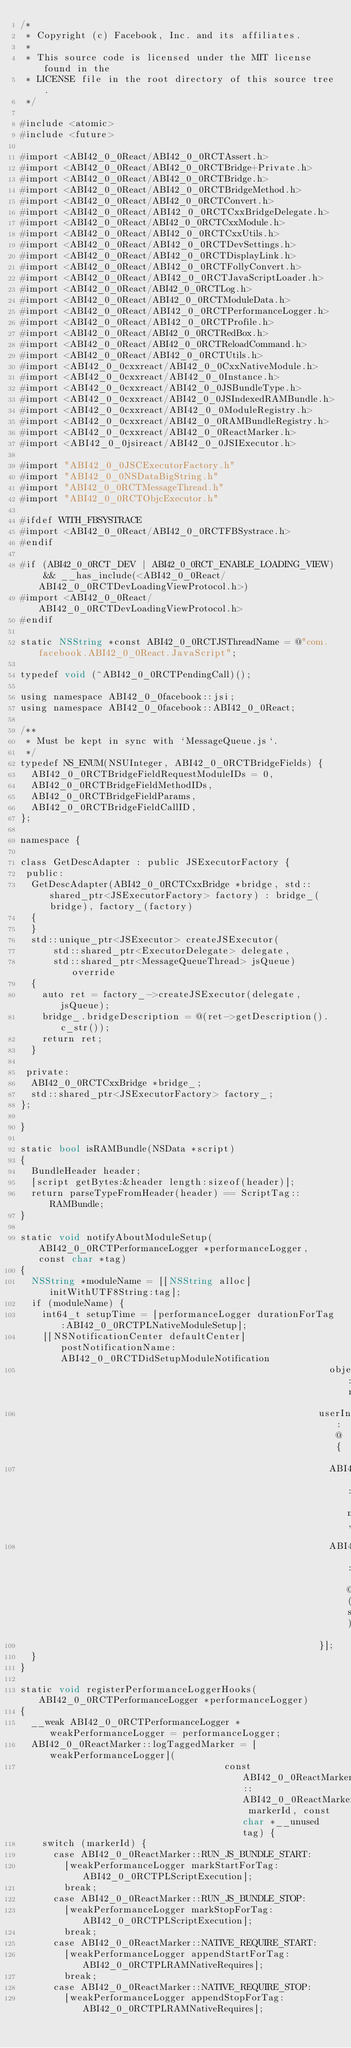Convert code to text. <code><loc_0><loc_0><loc_500><loc_500><_ObjectiveC_>/*
 * Copyright (c) Facebook, Inc. and its affiliates.
 *
 * This source code is licensed under the MIT license found in the
 * LICENSE file in the root directory of this source tree.
 */

#include <atomic>
#include <future>

#import <ABI42_0_0React/ABI42_0_0RCTAssert.h>
#import <ABI42_0_0React/ABI42_0_0RCTBridge+Private.h>
#import <ABI42_0_0React/ABI42_0_0RCTBridge.h>
#import <ABI42_0_0React/ABI42_0_0RCTBridgeMethod.h>
#import <ABI42_0_0React/ABI42_0_0RCTConvert.h>
#import <ABI42_0_0React/ABI42_0_0RCTCxxBridgeDelegate.h>
#import <ABI42_0_0React/ABI42_0_0RCTCxxModule.h>
#import <ABI42_0_0React/ABI42_0_0RCTCxxUtils.h>
#import <ABI42_0_0React/ABI42_0_0RCTDevSettings.h>
#import <ABI42_0_0React/ABI42_0_0RCTDisplayLink.h>
#import <ABI42_0_0React/ABI42_0_0RCTFollyConvert.h>
#import <ABI42_0_0React/ABI42_0_0RCTJavaScriptLoader.h>
#import <ABI42_0_0React/ABI42_0_0RCTLog.h>
#import <ABI42_0_0React/ABI42_0_0RCTModuleData.h>
#import <ABI42_0_0React/ABI42_0_0RCTPerformanceLogger.h>
#import <ABI42_0_0React/ABI42_0_0RCTProfile.h>
#import <ABI42_0_0React/ABI42_0_0RCTRedBox.h>
#import <ABI42_0_0React/ABI42_0_0RCTReloadCommand.h>
#import <ABI42_0_0React/ABI42_0_0RCTUtils.h>
#import <ABI42_0_0cxxreact/ABI42_0_0CxxNativeModule.h>
#import <ABI42_0_0cxxreact/ABI42_0_0Instance.h>
#import <ABI42_0_0cxxreact/ABI42_0_0JSBundleType.h>
#import <ABI42_0_0cxxreact/ABI42_0_0JSIndexedRAMBundle.h>
#import <ABI42_0_0cxxreact/ABI42_0_0ModuleRegistry.h>
#import <ABI42_0_0cxxreact/ABI42_0_0RAMBundleRegistry.h>
#import <ABI42_0_0cxxreact/ABI42_0_0ReactMarker.h>
#import <ABI42_0_0jsireact/ABI42_0_0JSIExecutor.h>

#import "ABI42_0_0JSCExecutorFactory.h"
#import "ABI42_0_0NSDataBigString.h"
#import "ABI42_0_0RCTMessageThread.h"
#import "ABI42_0_0RCTObjcExecutor.h"

#ifdef WITH_FBSYSTRACE
#import <ABI42_0_0React/ABI42_0_0RCTFBSystrace.h>
#endif

#if (ABI42_0_0RCT_DEV | ABI42_0_0RCT_ENABLE_LOADING_VIEW) && __has_include(<ABI42_0_0React/ABI42_0_0RCTDevLoadingViewProtocol.h>)
#import <ABI42_0_0React/ABI42_0_0RCTDevLoadingViewProtocol.h>
#endif

static NSString *const ABI42_0_0RCTJSThreadName = @"com.facebook.ABI42_0_0React.JavaScript";

typedef void (^ABI42_0_0RCTPendingCall)();

using namespace ABI42_0_0facebook::jsi;
using namespace ABI42_0_0facebook::ABI42_0_0React;

/**
 * Must be kept in sync with `MessageQueue.js`.
 */
typedef NS_ENUM(NSUInteger, ABI42_0_0RCTBridgeFields) {
  ABI42_0_0RCTBridgeFieldRequestModuleIDs = 0,
  ABI42_0_0RCTBridgeFieldMethodIDs,
  ABI42_0_0RCTBridgeFieldParams,
  ABI42_0_0RCTBridgeFieldCallID,
};

namespace {

class GetDescAdapter : public JSExecutorFactory {
 public:
  GetDescAdapter(ABI42_0_0RCTCxxBridge *bridge, std::shared_ptr<JSExecutorFactory> factory) : bridge_(bridge), factory_(factory)
  {
  }
  std::unique_ptr<JSExecutor> createJSExecutor(
      std::shared_ptr<ExecutorDelegate> delegate,
      std::shared_ptr<MessageQueueThread> jsQueue) override
  {
    auto ret = factory_->createJSExecutor(delegate, jsQueue);
    bridge_.bridgeDescription = @(ret->getDescription().c_str());
    return ret;
  }

 private:
  ABI42_0_0RCTCxxBridge *bridge_;
  std::shared_ptr<JSExecutorFactory> factory_;
};

}

static bool isRAMBundle(NSData *script)
{
  BundleHeader header;
  [script getBytes:&header length:sizeof(header)];
  return parseTypeFromHeader(header) == ScriptTag::RAMBundle;
}

static void notifyAboutModuleSetup(ABI42_0_0RCTPerformanceLogger *performanceLogger, const char *tag)
{
  NSString *moduleName = [[NSString alloc] initWithUTF8String:tag];
  if (moduleName) {
    int64_t setupTime = [performanceLogger durationForTag:ABI42_0_0RCTPLNativeModuleSetup];
    [[NSNotificationCenter defaultCenter] postNotificationName:ABI42_0_0RCTDidSetupModuleNotification
                                                        object:nil
                                                      userInfo:@{
                                                        ABI42_0_0RCTDidSetupModuleNotificationModuleNameKey : moduleName,
                                                        ABI42_0_0RCTDidSetupModuleNotificationSetupTimeKey : @(setupTime)
                                                      }];
  }
}

static void registerPerformanceLoggerHooks(ABI42_0_0RCTPerformanceLogger *performanceLogger)
{
  __weak ABI42_0_0RCTPerformanceLogger *weakPerformanceLogger = performanceLogger;
  ABI42_0_0ReactMarker::logTaggedMarker = [weakPerformanceLogger](
                                     const ABI42_0_0ReactMarker::ABI42_0_0ReactMarkerId markerId, const char *__unused tag) {
    switch (markerId) {
      case ABI42_0_0ReactMarker::RUN_JS_BUNDLE_START:
        [weakPerformanceLogger markStartForTag:ABI42_0_0RCTPLScriptExecution];
        break;
      case ABI42_0_0ReactMarker::RUN_JS_BUNDLE_STOP:
        [weakPerformanceLogger markStopForTag:ABI42_0_0RCTPLScriptExecution];
        break;
      case ABI42_0_0ReactMarker::NATIVE_REQUIRE_START:
        [weakPerformanceLogger appendStartForTag:ABI42_0_0RCTPLRAMNativeRequires];
        break;
      case ABI42_0_0ReactMarker::NATIVE_REQUIRE_STOP:
        [weakPerformanceLogger appendStopForTag:ABI42_0_0RCTPLRAMNativeRequires];</code> 